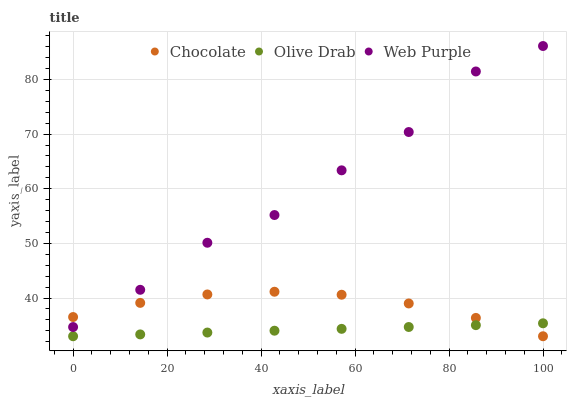Does Olive Drab have the minimum area under the curve?
Answer yes or no. Yes. Does Web Purple have the maximum area under the curve?
Answer yes or no. Yes. Does Chocolate have the minimum area under the curve?
Answer yes or no. No. Does Chocolate have the maximum area under the curve?
Answer yes or no. No. Is Olive Drab the smoothest?
Answer yes or no. Yes. Is Web Purple the roughest?
Answer yes or no. Yes. Is Chocolate the smoothest?
Answer yes or no. No. Is Chocolate the roughest?
Answer yes or no. No. Does Olive Drab have the lowest value?
Answer yes or no. Yes. Does Web Purple have the highest value?
Answer yes or no. Yes. Does Chocolate have the highest value?
Answer yes or no. No. Is Olive Drab less than Web Purple?
Answer yes or no. Yes. Is Web Purple greater than Olive Drab?
Answer yes or no. Yes. Does Chocolate intersect Web Purple?
Answer yes or no. Yes. Is Chocolate less than Web Purple?
Answer yes or no. No. Is Chocolate greater than Web Purple?
Answer yes or no. No. Does Olive Drab intersect Web Purple?
Answer yes or no. No. 